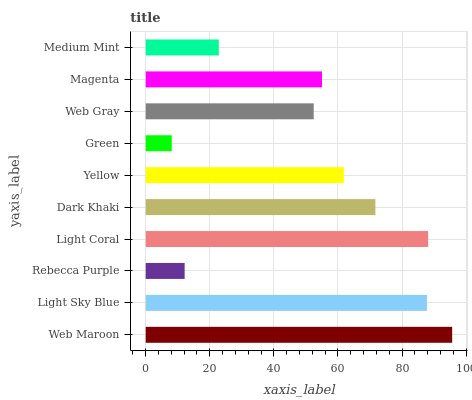Is Green the minimum?
Answer yes or no. Yes. Is Web Maroon the maximum?
Answer yes or no. Yes. Is Light Sky Blue the minimum?
Answer yes or no. No. Is Light Sky Blue the maximum?
Answer yes or no. No. Is Web Maroon greater than Light Sky Blue?
Answer yes or no. Yes. Is Light Sky Blue less than Web Maroon?
Answer yes or no. Yes. Is Light Sky Blue greater than Web Maroon?
Answer yes or no. No. Is Web Maroon less than Light Sky Blue?
Answer yes or no. No. Is Yellow the high median?
Answer yes or no. Yes. Is Magenta the low median?
Answer yes or no. Yes. Is Web Gray the high median?
Answer yes or no. No. Is Web Maroon the low median?
Answer yes or no. No. 